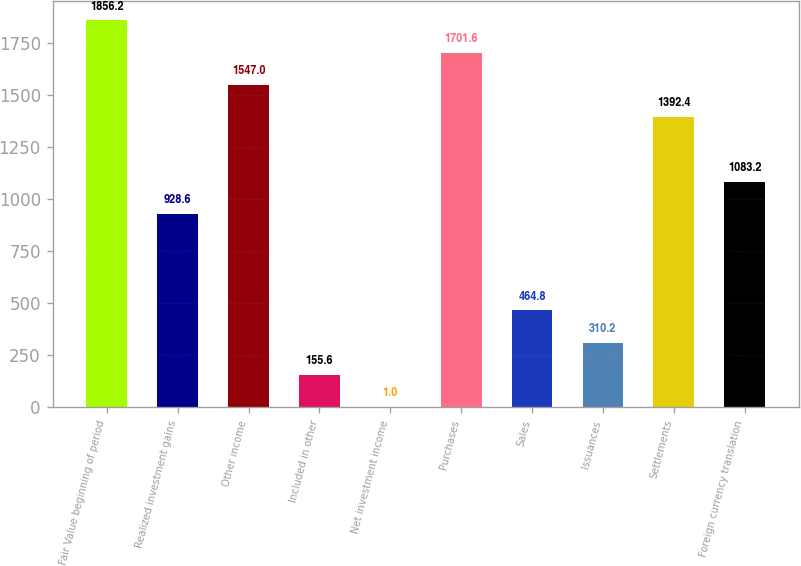Convert chart. <chart><loc_0><loc_0><loc_500><loc_500><bar_chart><fcel>Fair Value beginning of period<fcel>Realized investment gains<fcel>Other income<fcel>Included in other<fcel>Net investment income<fcel>Purchases<fcel>Sales<fcel>Issuances<fcel>Settlements<fcel>Foreign currency translation<nl><fcel>1856.2<fcel>928.6<fcel>1547<fcel>155.6<fcel>1<fcel>1701.6<fcel>464.8<fcel>310.2<fcel>1392.4<fcel>1083.2<nl></chart> 